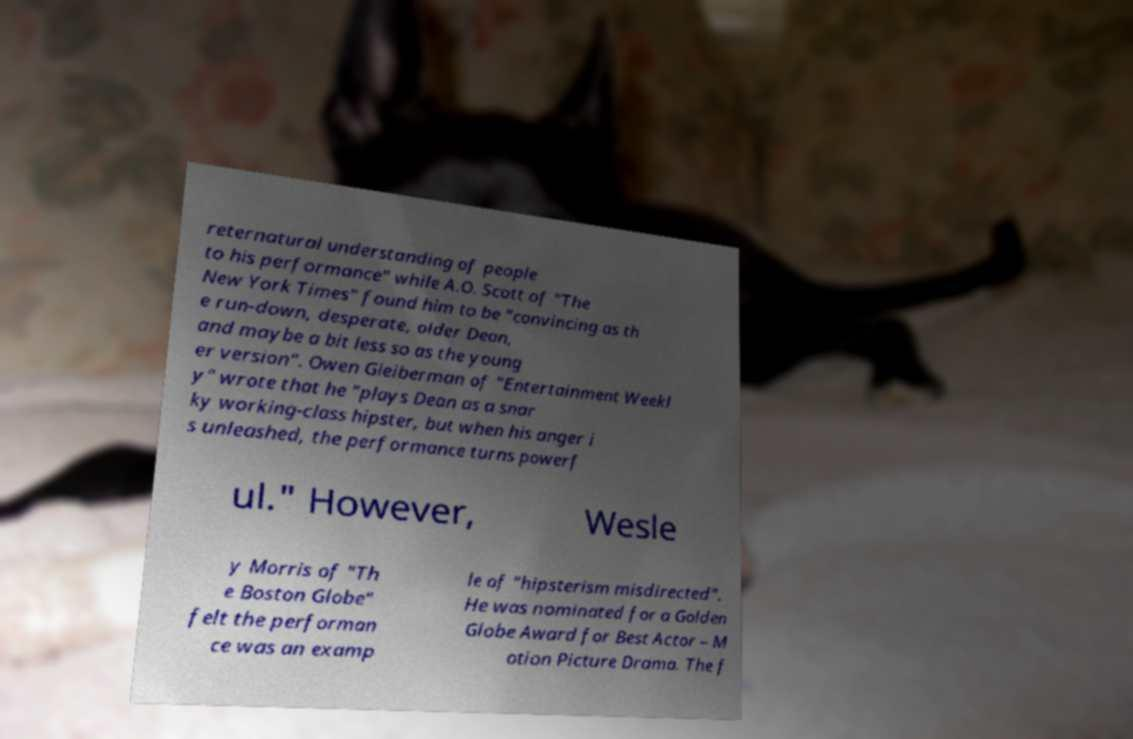I need the written content from this picture converted into text. Can you do that? reternatural understanding of people to his performance" while A.O. Scott of "The New York Times" found him to be "convincing as th e run-down, desperate, older Dean, and maybe a bit less so as the young er version". Owen Gleiberman of "Entertainment Weekl y" wrote that he "plays Dean as a snar ky working-class hipster, but when his anger i s unleashed, the performance turns powerf ul." However, Wesle y Morris of "Th e Boston Globe" felt the performan ce was an examp le of "hipsterism misdirected". He was nominated for a Golden Globe Award for Best Actor – M otion Picture Drama. The f 